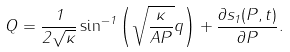<formula> <loc_0><loc_0><loc_500><loc_500>Q = \frac { 1 } { 2 \sqrt { \kappa } } \sin ^ { - 1 } \left ( \sqrt { \frac { \kappa } { A P } } q \right ) + \frac { \partial s _ { 1 } ( P , t ) } { \partial P } .</formula> 